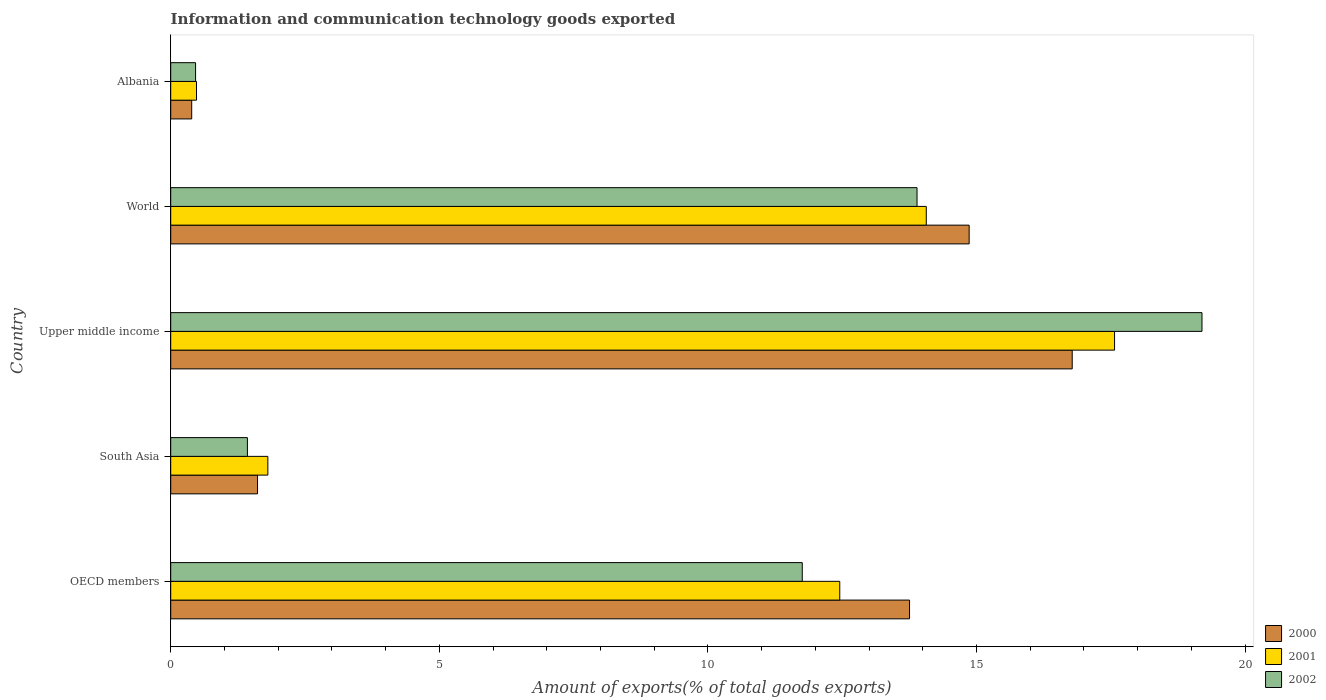How many groups of bars are there?
Make the answer very short. 5. Are the number of bars per tick equal to the number of legend labels?
Offer a very short reply. Yes. How many bars are there on the 5th tick from the bottom?
Your answer should be compact. 3. What is the label of the 2nd group of bars from the top?
Offer a terse response. World. What is the amount of goods exported in 2001 in Upper middle income?
Give a very brief answer. 17.57. Across all countries, what is the maximum amount of goods exported in 2000?
Your response must be concise. 16.78. Across all countries, what is the minimum amount of goods exported in 2000?
Ensure brevity in your answer.  0.39. In which country was the amount of goods exported in 2002 maximum?
Keep it short and to the point. Upper middle income. In which country was the amount of goods exported in 2001 minimum?
Your answer should be very brief. Albania. What is the total amount of goods exported in 2002 in the graph?
Your answer should be compact. 46.74. What is the difference between the amount of goods exported in 2000 in OECD members and that in World?
Your answer should be compact. -1.11. What is the difference between the amount of goods exported in 2000 in Upper middle income and the amount of goods exported in 2002 in World?
Provide a succinct answer. 2.89. What is the average amount of goods exported in 2001 per country?
Keep it short and to the point. 9.28. What is the difference between the amount of goods exported in 2000 and amount of goods exported in 2002 in World?
Provide a short and direct response. 0.97. What is the ratio of the amount of goods exported in 2002 in Albania to that in OECD members?
Your response must be concise. 0.04. Is the difference between the amount of goods exported in 2000 in South Asia and Upper middle income greater than the difference between the amount of goods exported in 2002 in South Asia and Upper middle income?
Ensure brevity in your answer.  Yes. What is the difference between the highest and the second highest amount of goods exported in 2000?
Provide a short and direct response. 1.92. What is the difference between the highest and the lowest amount of goods exported in 2002?
Give a very brief answer. 18.73. In how many countries, is the amount of goods exported in 2000 greater than the average amount of goods exported in 2000 taken over all countries?
Your answer should be very brief. 3. What does the 2nd bar from the bottom in World represents?
Provide a succinct answer. 2001. How many bars are there?
Your response must be concise. 15. How many countries are there in the graph?
Provide a short and direct response. 5. What is the difference between two consecutive major ticks on the X-axis?
Provide a short and direct response. 5. Does the graph contain any zero values?
Your answer should be compact. No. Where does the legend appear in the graph?
Your answer should be compact. Bottom right. How are the legend labels stacked?
Offer a very short reply. Vertical. What is the title of the graph?
Provide a short and direct response. Information and communication technology goods exported. What is the label or title of the X-axis?
Offer a terse response. Amount of exports(% of total goods exports). What is the label or title of the Y-axis?
Your response must be concise. Country. What is the Amount of exports(% of total goods exports) in 2000 in OECD members?
Keep it short and to the point. 13.75. What is the Amount of exports(% of total goods exports) in 2001 in OECD members?
Give a very brief answer. 12.45. What is the Amount of exports(% of total goods exports) of 2002 in OECD members?
Offer a very short reply. 11.76. What is the Amount of exports(% of total goods exports) in 2000 in South Asia?
Provide a short and direct response. 1.62. What is the Amount of exports(% of total goods exports) of 2001 in South Asia?
Provide a succinct answer. 1.81. What is the Amount of exports(% of total goods exports) of 2002 in South Asia?
Your answer should be very brief. 1.43. What is the Amount of exports(% of total goods exports) of 2000 in Upper middle income?
Your answer should be compact. 16.78. What is the Amount of exports(% of total goods exports) in 2001 in Upper middle income?
Provide a short and direct response. 17.57. What is the Amount of exports(% of total goods exports) in 2002 in Upper middle income?
Ensure brevity in your answer.  19.2. What is the Amount of exports(% of total goods exports) of 2000 in World?
Offer a terse response. 14.86. What is the Amount of exports(% of total goods exports) of 2001 in World?
Make the answer very short. 14.06. What is the Amount of exports(% of total goods exports) of 2002 in World?
Ensure brevity in your answer.  13.89. What is the Amount of exports(% of total goods exports) in 2000 in Albania?
Give a very brief answer. 0.39. What is the Amount of exports(% of total goods exports) in 2001 in Albania?
Offer a very short reply. 0.48. What is the Amount of exports(% of total goods exports) in 2002 in Albania?
Ensure brevity in your answer.  0.46. Across all countries, what is the maximum Amount of exports(% of total goods exports) of 2000?
Your answer should be compact. 16.78. Across all countries, what is the maximum Amount of exports(% of total goods exports) of 2001?
Your answer should be very brief. 17.57. Across all countries, what is the maximum Amount of exports(% of total goods exports) in 2002?
Offer a terse response. 19.2. Across all countries, what is the minimum Amount of exports(% of total goods exports) of 2000?
Offer a very short reply. 0.39. Across all countries, what is the minimum Amount of exports(% of total goods exports) of 2001?
Make the answer very short. 0.48. Across all countries, what is the minimum Amount of exports(% of total goods exports) in 2002?
Keep it short and to the point. 0.46. What is the total Amount of exports(% of total goods exports) of 2000 in the graph?
Ensure brevity in your answer.  47.41. What is the total Amount of exports(% of total goods exports) of 2001 in the graph?
Your response must be concise. 46.38. What is the total Amount of exports(% of total goods exports) of 2002 in the graph?
Give a very brief answer. 46.74. What is the difference between the Amount of exports(% of total goods exports) in 2000 in OECD members and that in South Asia?
Your answer should be very brief. 12.14. What is the difference between the Amount of exports(% of total goods exports) of 2001 in OECD members and that in South Asia?
Your answer should be compact. 10.65. What is the difference between the Amount of exports(% of total goods exports) of 2002 in OECD members and that in South Asia?
Give a very brief answer. 10.33. What is the difference between the Amount of exports(% of total goods exports) of 2000 in OECD members and that in Upper middle income?
Ensure brevity in your answer.  -3.03. What is the difference between the Amount of exports(% of total goods exports) of 2001 in OECD members and that in Upper middle income?
Your response must be concise. -5.12. What is the difference between the Amount of exports(% of total goods exports) in 2002 in OECD members and that in Upper middle income?
Keep it short and to the point. -7.44. What is the difference between the Amount of exports(% of total goods exports) of 2000 in OECD members and that in World?
Your response must be concise. -1.11. What is the difference between the Amount of exports(% of total goods exports) in 2001 in OECD members and that in World?
Offer a terse response. -1.61. What is the difference between the Amount of exports(% of total goods exports) in 2002 in OECD members and that in World?
Make the answer very short. -2.14. What is the difference between the Amount of exports(% of total goods exports) of 2000 in OECD members and that in Albania?
Provide a succinct answer. 13.36. What is the difference between the Amount of exports(% of total goods exports) of 2001 in OECD members and that in Albania?
Keep it short and to the point. 11.97. What is the difference between the Amount of exports(% of total goods exports) in 2002 in OECD members and that in Albania?
Offer a very short reply. 11.29. What is the difference between the Amount of exports(% of total goods exports) of 2000 in South Asia and that in Upper middle income?
Give a very brief answer. -15.17. What is the difference between the Amount of exports(% of total goods exports) of 2001 in South Asia and that in Upper middle income?
Your response must be concise. -15.76. What is the difference between the Amount of exports(% of total goods exports) of 2002 in South Asia and that in Upper middle income?
Ensure brevity in your answer.  -17.77. What is the difference between the Amount of exports(% of total goods exports) in 2000 in South Asia and that in World?
Your response must be concise. -13.25. What is the difference between the Amount of exports(% of total goods exports) in 2001 in South Asia and that in World?
Offer a very short reply. -12.26. What is the difference between the Amount of exports(% of total goods exports) in 2002 in South Asia and that in World?
Make the answer very short. -12.47. What is the difference between the Amount of exports(% of total goods exports) in 2000 in South Asia and that in Albania?
Provide a short and direct response. 1.23. What is the difference between the Amount of exports(% of total goods exports) in 2001 in South Asia and that in Albania?
Your answer should be compact. 1.33. What is the difference between the Amount of exports(% of total goods exports) of 2002 in South Asia and that in Albania?
Give a very brief answer. 0.96. What is the difference between the Amount of exports(% of total goods exports) of 2000 in Upper middle income and that in World?
Your answer should be very brief. 1.92. What is the difference between the Amount of exports(% of total goods exports) in 2001 in Upper middle income and that in World?
Make the answer very short. 3.5. What is the difference between the Amount of exports(% of total goods exports) of 2002 in Upper middle income and that in World?
Give a very brief answer. 5.3. What is the difference between the Amount of exports(% of total goods exports) of 2000 in Upper middle income and that in Albania?
Offer a very short reply. 16.39. What is the difference between the Amount of exports(% of total goods exports) of 2001 in Upper middle income and that in Albania?
Ensure brevity in your answer.  17.09. What is the difference between the Amount of exports(% of total goods exports) of 2002 in Upper middle income and that in Albania?
Offer a very short reply. 18.73. What is the difference between the Amount of exports(% of total goods exports) of 2000 in World and that in Albania?
Provide a succinct answer. 14.47. What is the difference between the Amount of exports(% of total goods exports) in 2001 in World and that in Albania?
Offer a very short reply. 13.58. What is the difference between the Amount of exports(% of total goods exports) of 2002 in World and that in Albania?
Offer a very short reply. 13.43. What is the difference between the Amount of exports(% of total goods exports) of 2000 in OECD members and the Amount of exports(% of total goods exports) of 2001 in South Asia?
Provide a succinct answer. 11.95. What is the difference between the Amount of exports(% of total goods exports) of 2000 in OECD members and the Amount of exports(% of total goods exports) of 2002 in South Asia?
Offer a terse response. 12.33. What is the difference between the Amount of exports(% of total goods exports) in 2001 in OECD members and the Amount of exports(% of total goods exports) in 2002 in South Asia?
Ensure brevity in your answer.  11.03. What is the difference between the Amount of exports(% of total goods exports) in 2000 in OECD members and the Amount of exports(% of total goods exports) in 2001 in Upper middle income?
Provide a succinct answer. -3.82. What is the difference between the Amount of exports(% of total goods exports) in 2000 in OECD members and the Amount of exports(% of total goods exports) in 2002 in Upper middle income?
Your answer should be compact. -5.44. What is the difference between the Amount of exports(% of total goods exports) in 2001 in OECD members and the Amount of exports(% of total goods exports) in 2002 in Upper middle income?
Your answer should be very brief. -6.74. What is the difference between the Amount of exports(% of total goods exports) of 2000 in OECD members and the Amount of exports(% of total goods exports) of 2001 in World?
Your answer should be compact. -0.31. What is the difference between the Amount of exports(% of total goods exports) in 2000 in OECD members and the Amount of exports(% of total goods exports) in 2002 in World?
Keep it short and to the point. -0.14. What is the difference between the Amount of exports(% of total goods exports) in 2001 in OECD members and the Amount of exports(% of total goods exports) in 2002 in World?
Your response must be concise. -1.44. What is the difference between the Amount of exports(% of total goods exports) of 2000 in OECD members and the Amount of exports(% of total goods exports) of 2001 in Albania?
Give a very brief answer. 13.27. What is the difference between the Amount of exports(% of total goods exports) in 2000 in OECD members and the Amount of exports(% of total goods exports) in 2002 in Albania?
Ensure brevity in your answer.  13.29. What is the difference between the Amount of exports(% of total goods exports) in 2001 in OECD members and the Amount of exports(% of total goods exports) in 2002 in Albania?
Your answer should be compact. 11.99. What is the difference between the Amount of exports(% of total goods exports) of 2000 in South Asia and the Amount of exports(% of total goods exports) of 2001 in Upper middle income?
Your answer should be compact. -15.95. What is the difference between the Amount of exports(% of total goods exports) of 2000 in South Asia and the Amount of exports(% of total goods exports) of 2002 in Upper middle income?
Offer a terse response. -17.58. What is the difference between the Amount of exports(% of total goods exports) of 2001 in South Asia and the Amount of exports(% of total goods exports) of 2002 in Upper middle income?
Provide a succinct answer. -17.39. What is the difference between the Amount of exports(% of total goods exports) in 2000 in South Asia and the Amount of exports(% of total goods exports) in 2001 in World?
Provide a short and direct response. -12.45. What is the difference between the Amount of exports(% of total goods exports) of 2000 in South Asia and the Amount of exports(% of total goods exports) of 2002 in World?
Your answer should be compact. -12.28. What is the difference between the Amount of exports(% of total goods exports) in 2001 in South Asia and the Amount of exports(% of total goods exports) in 2002 in World?
Give a very brief answer. -12.08. What is the difference between the Amount of exports(% of total goods exports) in 2000 in South Asia and the Amount of exports(% of total goods exports) in 2001 in Albania?
Make the answer very short. 1.14. What is the difference between the Amount of exports(% of total goods exports) of 2000 in South Asia and the Amount of exports(% of total goods exports) of 2002 in Albania?
Give a very brief answer. 1.15. What is the difference between the Amount of exports(% of total goods exports) in 2001 in South Asia and the Amount of exports(% of total goods exports) in 2002 in Albania?
Your answer should be very brief. 1.35. What is the difference between the Amount of exports(% of total goods exports) of 2000 in Upper middle income and the Amount of exports(% of total goods exports) of 2001 in World?
Provide a succinct answer. 2.72. What is the difference between the Amount of exports(% of total goods exports) in 2000 in Upper middle income and the Amount of exports(% of total goods exports) in 2002 in World?
Keep it short and to the point. 2.89. What is the difference between the Amount of exports(% of total goods exports) of 2001 in Upper middle income and the Amount of exports(% of total goods exports) of 2002 in World?
Make the answer very short. 3.68. What is the difference between the Amount of exports(% of total goods exports) in 2000 in Upper middle income and the Amount of exports(% of total goods exports) in 2001 in Albania?
Keep it short and to the point. 16.3. What is the difference between the Amount of exports(% of total goods exports) of 2000 in Upper middle income and the Amount of exports(% of total goods exports) of 2002 in Albania?
Your answer should be compact. 16.32. What is the difference between the Amount of exports(% of total goods exports) in 2001 in Upper middle income and the Amount of exports(% of total goods exports) in 2002 in Albania?
Your answer should be compact. 17.11. What is the difference between the Amount of exports(% of total goods exports) in 2000 in World and the Amount of exports(% of total goods exports) in 2001 in Albania?
Your response must be concise. 14.38. What is the difference between the Amount of exports(% of total goods exports) in 2000 in World and the Amount of exports(% of total goods exports) in 2002 in Albania?
Your answer should be compact. 14.4. What is the difference between the Amount of exports(% of total goods exports) of 2001 in World and the Amount of exports(% of total goods exports) of 2002 in Albania?
Your answer should be very brief. 13.6. What is the average Amount of exports(% of total goods exports) in 2000 per country?
Your answer should be very brief. 9.48. What is the average Amount of exports(% of total goods exports) in 2001 per country?
Your answer should be very brief. 9.28. What is the average Amount of exports(% of total goods exports) in 2002 per country?
Keep it short and to the point. 9.35. What is the difference between the Amount of exports(% of total goods exports) in 2000 and Amount of exports(% of total goods exports) in 2001 in OECD members?
Your answer should be very brief. 1.3. What is the difference between the Amount of exports(% of total goods exports) in 2000 and Amount of exports(% of total goods exports) in 2002 in OECD members?
Offer a very short reply. 2. What is the difference between the Amount of exports(% of total goods exports) of 2001 and Amount of exports(% of total goods exports) of 2002 in OECD members?
Offer a terse response. 0.7. What is the difference between the Amount of exports(% of total goods exports) of 2000 and Amount of exports(% of total goods exports) of 2001 in South Asia?
Provide a succinct answer. -0.19. What is the difference between the Amount of exports(% of total goods exports) in 2000 and Amount of exports(% of total goods exports) in 2002 in South Asia?
Ensure brevity in your answer.  0.19. What is the difference between the Amount of exports(% of total goods exports) of 2001 and Amount of exports(% of total goods exports) of 2002 in South Asia?
Keep it short and to the point. 0.38. What is the difference between the Amount of exports(% of total goods exports) of 2000 and Amount of exports(% of total goods exports) of 2001 in Upper middle income?
Your answer should be compact. -0.79. What is the difference between the Amount of exports(% of total goods exports) in 2000 and Amount of exports(% of total goods exports) in 2002 in Upper middle income?
Offer a very short reply. -2.42. What is the difference between the Amount of exports(% of total goods exports) in 2001 and Amount of exports(% of total goods exports) in 2002 in Upper middle income?
Make the answer very short. -1.63. What is the difference between the Amount of exports(% of total goods exports) of 2000 and Amount of exports(% of total goods exports) of 2001 in World?
Offer a terse response. 0.8. What is the difference between the Amount of exports(% of total goods exports) in 2000 and Amount of exports(% of total goods exports) in 2002 in World?
Your answer should be compact. 0.97. What is the difference between the Amount of exports(% of total goods exports) of 2001 and Amount of exports(% of total goods exports) of 2002 in World?
Provide a short and direct response. 0.17. What is the difference between the Amount of exports(% of total goods exports) in 2000 and Amount of exports(% of total goods exports) in 2001 in Albania?
Provide a succinct answer. -0.09. What is the difference between the Amount of exports(% of total goods exports) in 2000 and Amount of exports(% of total goods exports) in 2002 in Albania?
Offer a very short reply. -0.07. What is the difference between the Amount of exports(% of total goods exports) of 2001 and Amount of exports(% of total goods exports) of 2002 in Albania?
Offer a very short reply. 0.02. What is the ratio of the Amount of exports(% of total goods exports) in 2000 in OECD members to that in South Asia?
Your response must be concise. 8.51. What is the ratio of the Amount of exports(% of total goods exports) of 2001 in OECD members to that in South Asia?
Make the answer very short. 6.89. What is the ratio of the Amount of exports(% of total goods exports) of 2002 in OECD members to that in South Asia?
Your answer should be very brief. 8.23. What is the ratio of the Amount of exports(% of total goods exports) of 2000 in OECD members to that in Upper middle income?
Ensure brevity in your answer.  0.82. What is the ratio of the Amount of exports(% of total goods exports) in 2001 in OECD members to that in Upper middle income?
Give a very brief answer. 0.71. What is the ratio of the Amount of exports(% of total goods exports) of 2002 in OECD members to that in Upper middle income?
Your response must be concise. 0.61. What is the ratio of the Amount of exports(% of total goods exports) in 2000 in OECD members to that in World?
Provide a succinct answer. 0.93. What is the ratio of the Amount of exports(% of total goods exports) of 2001 in OECD members to that in World?
Your answer should be very brief. 0.89. What is the ratio of the Amount of exports(% of total goods exports) in 2002 in OECD members to that in World?
Your answer should be compact. 0.85. What is the ratio of the Amount of exports(% of total goods exports) in 2000 in OECD members to that in Albania?
Make the answer very short. 35.21. What is the ratio of the Amount of exports(% of total goods exports) in 2001 in OECD members to that in Albania?
Offer a very short reply. 25.94. What is the ratio of the Amount of exports(% of total goods exports) of 2002 in OECD members to that in Albania?
Give a very brief answer. 25.4. What is the ratio of the Amount of exports(% of total goods exports) in 2000 in South Asia to that in Upper middle income?
Ensure brevity in your answer.  0.1. What is the ratio of the Amount of exports(% of total goods exports) of 2001 in South Asia to that in Upper middle income?
Ensure brevity in your answer.  0.1. What is the ratio of the Amount of exports(% of total goods exports) in 2002 in South Asia to that in Upper middle income?
Your answer should be compact. 0.07. What is the ratio of the Amount of exports(% of total goods exports) in 2000 in South Asia to that in World?
Your answer should be compact. 0.11. What is the ratio of the Amount of exports(% of total goods exports) of 2001 in South Asia to that in World?
Make the answer very short. 0.13. What is the ratio of the Amount of exports(% of total goods exports) in 2002 in South Asia to that in World?
Ensure brevity in your answer.  0.1. What is the ratio of the Amount of exports(% of total goods exports) of 2000 in South Asia to that in Albania?
Your answer should be compact. 4.14. What is the ratio of the Amount of exports(% of total goods exports) in 2001 in South Asia to that in Albania?
Make the answer very short. 3.77. What is the ratio of the Amount of exports(% of total goods exports) in 2002 in South Asia to that in Albania?
Your response must be concise. 3.08. What is the ratio of the Amount of exports(% of total goods exports) in 2000 in Upper middle income to that in World?
Your answer should be very brief. 1.13. What is the ratio of the Amount of exports(% of total goods exports) of 2001 in Upper middle income to that in World?
Offer a terse response. 1.25. What is the ratio of the Amount of exports(% of total goods exports) in 2002 in Upper middle income to that in World?
Keep it short and to the point. 1.38. What is the ratio of the Amount of exports(% of total goods exports) of 2000 in Upper middle income to that in Albania?
Your answer should be compact. 42.96. What is the ratio of the Amount of exports(% of total goods exports) of 2001 in Upper middle income to that in Albania?
Keep it short and to the point. 36.6. What is the ratio of the Amount of exports(% of total goods exports) in 2002 in Upper middle income to that in Albania?
Make the answer very short. 41.48. What is the ratio of the Amount of exports(% of total goods exports) of 2000 in World to that in Albania?
Offer a very short reply. 38.05. What is the ratio of the Amount of exports(% of total goods exports) of 2001 in World to that in Albania?
Ensure brevity in your answer.  29.3. What is the ratio of the Amount of exports(% of total goods exports) in 2002 in World to that in Albania?
Offer a terse response. 30.02. What is the difference between the highest and the second highest Amount of exports(% of total goods exports) of 2000?
Your response must be concise. 1.92. What is the difference between the highest and the second highest Amount of exports(% of total goods exports) of 2001?
Your response must be concise. 3.5. What is the difference between the highest and the second highest Amount of exports(% of total goods exports) of 2002?
Ensure brevity in your answer.  5.3. What is the difference between the highest and the lowest Amount of exports(% of total goods exports) of 2000?
Ensure brevity in your answer.  16.39. What is the difference between the highest and the lowest Amount of exports(% of total goods exports) of 2001?
Keep it short and to the point. 17.09. What is the difference between the highest and the lowest Amount of exports(% of total goods exports) in 2002?
Offer a very short reply. 18.73. 